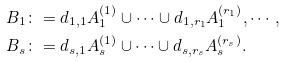<formula> <loc_0><loc_0><loc_500><loc_500>B _ { 1 } & \colon = d _ { 1 , 1 } A _ { 1 } ^ { ( 1 ) } \cup \dots \cup d _ { 1 , r _ { 1 } } A _ { 1 } ^ { ( r _ { 1 } ) } , \cdots , \\ B _ { s } & \colon = d _ { s , 1 } A _ { s } ^ { ( 1 ) } \cup \dots \cup d _ { s , r _ { s } } A _ { s } ^ { ( r _ { s } ) } .</formula> 